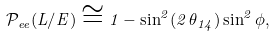Convert formula to latex. <formula><loc_0><loc_0><loc_500><loc_500>\mathcal { P } _ { e e } ( L / E ) \cong 1 - \sin ^ { 2 } ( 2 \, \theta _ { 1 4 } ) \sin ^ { 2 } \phi ,</formula> 